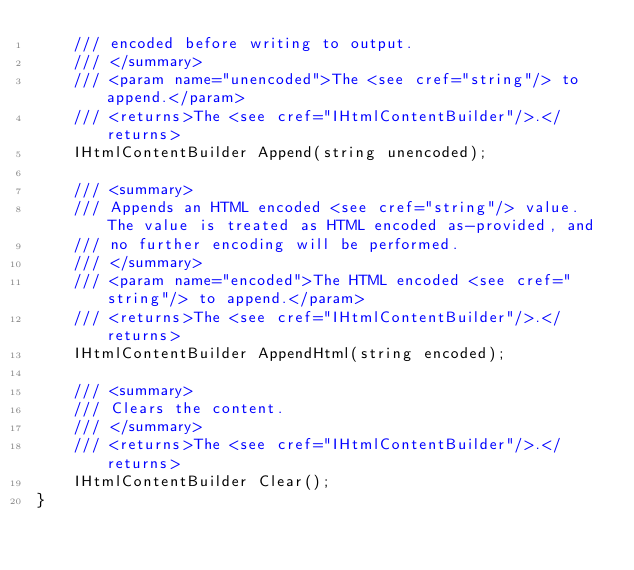<code> <loc_0><loc_0><loc_500><loc_500><_C#_>    /// encoded before writing to output.
    /// </summary>
    /// <param name="unencoded">The <see cref="string"/> to append.</param>
    /// <returns>The <see cref="IHtmlContentBuilder"/>.</returns>
    IHtmlContentBuilder Append(string unencoded);

    /// <summary>
    /// Appends an HTML encoded <see cref="string"/> value. The value is treated as HTML encoded as-provided, and
    /// no further encoding will be performed.
    /// </summary>
    /// <param name="encoded">The HTML encoded <see cref="string"/> to append.</param>
    /// <returns>The <see cref="IHtmlContentBuilder"/>.</returns>
    IHtmlContentBuilder AppendHtml(string encoded);

    /// <summary>
    /// Clears the content.
    /// </summary>
    /// <returns>The <see cref="IHtmlContentBuilder"/>.</returns>
    IHtmlContentBuilder Clear();
}
</code> 